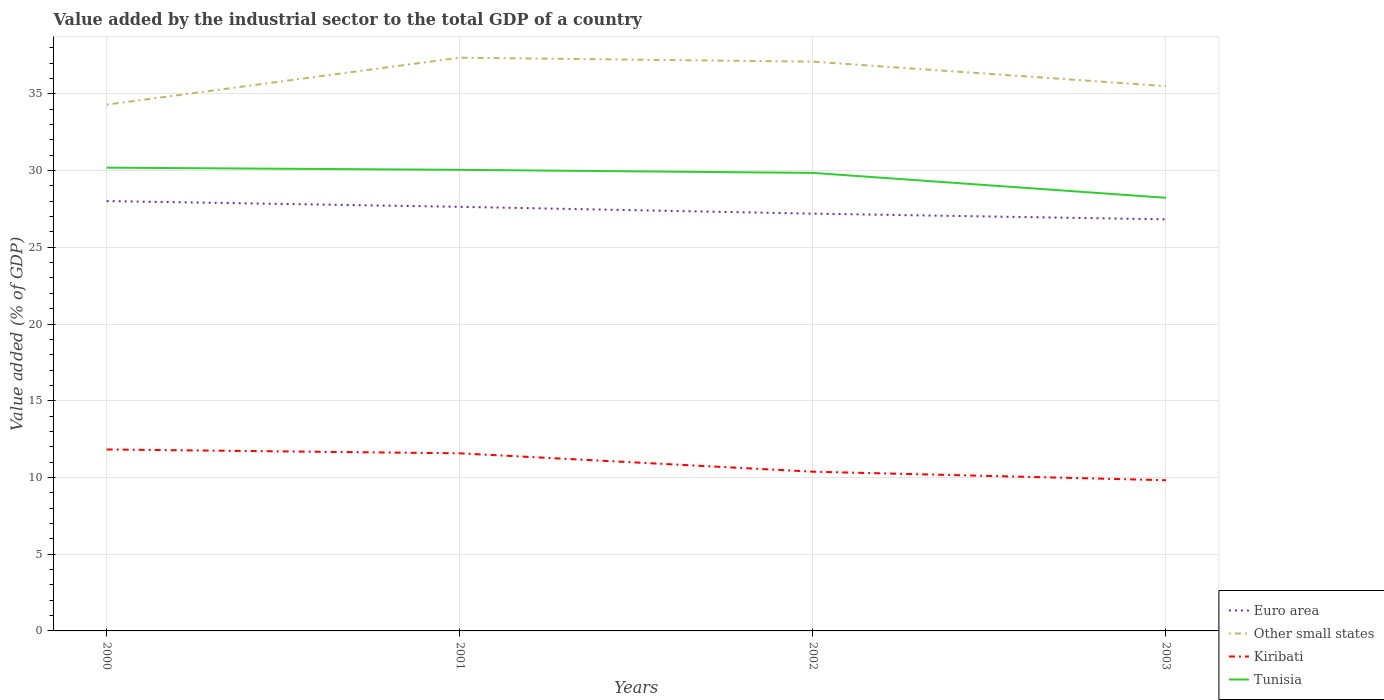Does the line corresponding to Kiribati intersect with the line corresponding to Tunisia?
Offer a very short reply. No. Across all years, what is the maximum value added by the industrial sector to the total GDP in Kiribati?
Your response must be concise. 9.82. What is the total value added by the industrial sector to the total GDP in Euro area in the graph?
Give a very brief answer. 0.45. What is the difference between the highest and the second highest value added by the industrial sector to the total GDP in Euro area?
Make the answer very short. 1.19. Is the value added by the industrial sector to the total GDP in Tunisia strictly greater than the value added by the industrial sector to the total GDP in Other small states over the years?
Your answer should be very brief. Yes. Are the values on the major ticks of Y-axis written in scientific E-notation?
Make the answer very short. No. Does the graph contain any zero values?
Give a very brief answer. No. Does the graph contain grids?
Give a very brief answer. Yes. What is the title of the graph?
Your answer should be compact. Value added by the industrial sector to the total GDP of a country. What is the label or title of the X-axis?
Offer a very short reply. Years. What is the label or title of the Y-axis?
Your answer should be compact. Value added (% of GDP). What is the Value added (% of GDP) in Euro area in 2000?
Provide a succinct answer. 28.01. What is the Value added (% of GDP) in Other small states in 2000?
Keep it short and to the point. 34.3. What is the Value added (% of GDP) in Kiribati in 2000?
Offer a terse response. 11.82. What is the Value added (% of GDP) of Tunisia in 2000?
Provide a short and direct response. 30.19. What is the Value added (% of GDP) of Euro area in 2001?
Your response must be concise. 27.64. What is the Value added (% of GDP) in Other small states in 2001?
Keep it short and to the point. 37.35. What is the Value added (% of GDP) in Kiribati in 2001?
Keep it short and to the point. 11.57. What is the Value added (% of GDP) in Tunisia in 2001?
Your answer should be very brief. 30.05. What is the Value added (% of GDP) of Euro area in 2002?
Provide a short and direct response. 27.19. What is the Value added (% of GDP) in Other small states in 2002?
Ensure brevity in your answer.  37.1. What is the Value added (% of GDP) of Kiribati in 2002?
Your answer should be very brief. 10.38. What is the Value added (% of GDP) of Tunisia in 2002?
Your answer should be very brief. 29.85. What is the Value added (% of GDP) of Euro area in 2003?
Provide a succinct answer. 26.82. What is the Value added (% of GDP) of Other small states in 2003?
Offer a terse response. 35.5. What is the Value added (% of GDP) in Kiribati in 2003?
Give a very brief answer. 9.82. What is the Value added (% of GDP) in Tunisia in 2003?
Offer a terse response. 28.23. Across all years, what is the maximum Value added (% of GDP) in Euro area?
Your response must be concise. 28.01. Across all years, what is the maximum Value added (% of GDP) in Other small states?
Your answer should be very brief. 37.35. Across all years, what is the maximum Value added (% of GDP) of Kiribati?
Make the answer very short. 11.82. Across all years, what is the maximum Value added (% of GDP) of Tunisia?
Make the answer very short. 30.19. Across all years, what is the minimum Value added (% of GDP) in Euro area?
Provide a short and direct response. 26.82. Across all years, what is the minimum Value added (% of GDP) of Other small states?
Your answer should be compact. 34.3. Across all years, what is the minimum Value added (% of GDP) in Kiribati?
Offer a very short reply. 9.82. Across all years, what is the minimum Value added (% of GDP) in Tunisia?
Keep it short and to the point. 28.23. What is the total Value added (% of GDP) in Euro area in the graph?
Offer a very short reply. 109.66. What is the total Value added (% of GDP) of Other small states in the graph?
Offer a terse response. 144.25. What is the total Value added (% of GDP) of Kiribati in the graph?
Keep it short and to the point. 43.6. What is the total Value added (% of GDP) of Tunisia in the graph?
Your answer should be very brief. 118.31. What is the difference between the Value added (% of GDP) of Euro area in 2000 and that in 2001?
Your answer should be compact. 0.37. What is the difference between the Value added (% of GDP) in Other small states in 2000 and that in 2001?
Provide a succinct answer. -3.06. What is the difference between the Value added (% of GDP) of Kiribati in 2000 and that in 2001?
Make the answer very short. 0.25. What is the difference between the Value added (% of GDP) of Tunisia in 2000 and that in 2001?
Provide a short and direct response. 0.14. What is the difference between the Value added (% of GDP) in Euro area in 2000 and that in 2002?
Keep it short and to the point. 0.82. What is the difference between the Value added (% of GDP) in Other small states in 2000 and that in 2002?
Offer a terse response. -2.8. What is the difference between the Value added (% of GDP) in Kiribati in 2000 and that in 2002?
Your response must be concise. 1.45. What is the difference between the Value added (% of GDP) in Tunisia in 2000 and that in 2002?
Keep it short and to the point. 0.34. What is the difference between the Value added (% of GDP) of Euro area in 2000 and that in 2003?
Provide a short and direct response. 1.19. What is the difference between the Value added (% of GDP) of Other small states in 2000 and that in 2003?
Ensure brevity in your answer.  -1.21. What is the difference between the Value added (% of GDP) in Kiribati in 2000 and that in 2003?
Keep it short and to the point. 2. What is the difference between the Value added (% of GDP) of Tunisia in 2000 and that in 2003?
Keep it short and to the point. 1.96. What is the difference between the Value added (% of GDP) in Euro area in 2001 and that in 2002?
Give a very brief answer. 0.45. What is the difference between the Value added (% of GDP) of Other small states in 2001 and that in 2002?
Offer a very short reply. 0.26. What is the difference between the Value added (% of GDP) in Kiribati in 2001 and that in 2002?
Offer a terse response. 1.2. What is the difference between the Value added (% of GDP) of Tunisia in 2001 and that in 2002?
Your answer should be compact. 0.2. What is the difference between the Value added (% of GDP) in Euro area in 2001 and that in 2003?
Your answer should be very brief. 0.82. What is the difference between the Value added (% of GDP) in Other small states in 2001 and that in 2003?
Offer a very short reply. 1.85. What is the difference between the Value added (% of GDP) of Kiribati in 2001 and that in 2003?
Give a very brief answer. 1.75. What is the difference between the Value added (% of GDP) of Tunisia in 2001 and that in 2003?
Your answer should be compact. 1.82. What is the difference between the Value added (% of GDP) of Euro area in 2002 and that in 2003?
Give a very brief answer. 0.37. What is the difference between the Value added (% of GDP) in Other small states in 2002 and that in 2003?
Ensure brevity in your answer.  1.59. What is the difference between the Value added (% of GDP) of Kiribati in 2002 and that in 2003?
Give a very brief answer. 0.55. What is the difference between the Value added (% of GDP) of Tunisia in 2002 and that in 2003?
Keep it short and to the point. 1.62. What is the difference between the Value added (% of GDP) of Euro area in 2000 and the Value added (% of GDP) of Other small states in 2001?
Your answer should be very brief. -9.34. What is the difference between the Value added (% of GDP) of Euro area in 2000 and the Value added (% of GDP) of Kiribati in 2001?
Keep it short and to the point. 16.44. What is the difference between the Value added (% of GDP) of Euro area in 2000 and the Value added (% of GDP) of Tunisia in 2001?
Make the answer very short. -2.04. What is the difference between the Value added (% of GDP) in Other small states in 2000 and the Value added (% of GDP) in Kiribati in 2001?
Make the answer very short. 22.72. What is the difference between the Value added (% of GDP) in Other small states in 2000 and the Value added (% of GDP) in Tunisia in 2001?
Give a very brief answer. 4.25. What is the difference between the Value added (% of GDP) in Kiribati in 2000 and the Value added (% of GDP) in Tunisia in 2001?
Keep it short and to the point. -18.22. What is the difference between the Value added (% of GDP) in Euro area in 2000 and the Value added (% of GDP) in Other small states in 2002?
Provide a short and direct response. -9.08. What is the difference between the Value added (% of GDP) in Euro area in 2000 and the Value added (% of GDP) in Kiribati in 2002?
Your response must be concise. 17.64. What is the difference between the Value added (% of GDP) of Euro area in 2000 and the Value added (% of GDP) of Tunisia in 2002?
Your answer should be compact. -1.84. What is the difference between the Value added (% of GDP) of Other small states in 2000 and the Value added (% of GDP) of Kiribati in 2002?
Ensure brevity in your answer.  23.92. What is the difference between the Value added (% of GDP) in Other small states in 2000 and the Value added (% of GDP) in Tunisia in 2002?
Your answer should be very brief. 4.45. What is the difference between the Value added (% of GDP) of Kiribati in 2000 and the Value added (% of GDP) of Tunisia in 2002?
Your answer should be very brief. -18.02. What is the difference between the Value added (% of GDP) of Euro area in 2000 and the Value added (% of GDP) of Other small states in 2003?
Your answer should be compact. -7.49. What is the difference between the Value added (% of GDP) in Euro area in 2000 and the Value added (% of GDP) in Kiribati in 2003?
Provide a short and direct response. 18.19. What is the difference between the Value added (% of GDP) in Euro area in 2000 and the Value added (% of GDP) in Tunisia in 2003?
Keep it short and to the point. -0.21. What is the difference between the Value added (% of GDP) in Other small states in 2000 and the Value added (% of GDP) in Kiribati in 2003?
Keep it short and to the point. 24.47. What is the difference between the Value added (% of GDP) in Other small states in 2000 and the Value added (% of GDP) in Tunisia in 2003?
Your answer should be very brief. 6.07. What is the difference between the Value added (% of GDP) in Kiribati in 2000 and the Value added (% of GDP) in Tunisia in 2003?
Keep it short and to the point. -16.4. What is the difference between the Value added (% of GDP) of Euro area in 2001 and the Value added (% of GDP) of Other small states in 2002?
Keep it short and to the point. -9.46. What is the difference between the Value added (% of GDP) of Euro area in 2001 and the Value added (% of GDP) of Kiribati in 2002?
Provide a short and direct response. 17.26. What is the difference between the Value added (% of GDP) in Euro area in 2001 and the Value added (% of GDP) in Tunisia in 2002?
Your response must be concise. -2.21. What is the difference between the Value added (% of GDP) in Other small states in 2001 and the Value added (% of GDP) in Kiribati in 2002?
Give a very brief answer. 26.98. What is the difference between the Value added (% of GDP) of Other small states in 2001 and the Value added (% of GDP) of Tunisia in 2002?
Offer a very short reply. 7.51. What is the difference between the Value added (% of GDP) in Kiribati in 2001 and the Value added (% of GDP) in Tunisia in 2002?
Make the answer very short. -18.27. What is the difference between the Value added (% of GDP) of Euro area in 2001 and the Value added (% of GDP) of Other small states in 2003?
Ensure brevity in your answer.  -7.87. What is the difference between the Value added (% of GDP) of Euro area in 2001 and the Value added (% of GDP) of Kiribati in 2003?
Provide a short and direct response. 17.82. What is the difference between the Value added (% of GDP) in Euro area in 2001 and the Value added (% of GDP) in Tunisia in 2003?
Ensure brevity in your answer.  -0.59. What is the difference between the Value added (% of GDP) in Other small states in 2001 and the Value added (% of GDP) in Kiribati in 2003?
Ensure brevity in your answer.  27.53. What is the difference between the Value added (% of GDP) of Other small states in 2001 and the Value added (% of GDP) of Tunisia in 2003?
Offer a terse response. 9.13. What is the difference between the Value added (% of GDP) in Kiribati in 2001 and the Value added (% of GDP) in Tunisia in 2003?
Ensure brevity in your answer.  -16.65. What is the difference between the Value added (% of GDP) in Euro area in 2002 and the Value added (% of GDP) in Other small states in 2003?
Provide a short and direct response. -8.31. What is the difference between the Value added (% of GDP) of Euro area in 2002 and the Value added (% of GDP) of Kiribati in 2003?
Provide a short and direct response. 17.37. What is the difference between the Value added (% of GDP) in Euro area in 2002 and the Value added (% of GDP) in Tunisia in 2003?
Give a very brief answer. -1.03. What is the difference between the Value added (% of GDP) in Other small states in 2002 and the Value added (% of GDP) in Kiribati in 2003?
Your answer should be very brief. 27.27. What is the difference between the Value added (% of GDP) in Other small states in 2002 and the Value added (% of GDP) in Tunisia in 2003?
Provide a short and direct response. 8.87. What is the difference between the Value added (% of GDP) in Kiribati in 2002 and the Value added (% of GDP) in Tunisia in 2003?
Offer a terse response. -17.85. What is the average Value added (% of GDP) in Euro area per year?
Make the answer very short. 27.42. What is the average Value added (% of GDP) in Other small states per year?
Give a very brief answer. 36.06. What is the average Value added (% of GDP) of Kiribati per year?
Offer a very short reply. 10.9. What is the average Value added (% of GDP) in Tunisia per year?
Offer a terse response. 29.58. In the year 2000, what is the difference between the Value added (% of GDP) in Euro area and Value added (% of GDP) in Other small states?
Offer a very short reply. -6.28. In the year 2000, what is the difference between the Value added (% of GDP) in Euro area and Value added (% of GDP) in Kiribati?
Offer a terse response. 16.19. In the year 2000, what is the difference between the Value added (% of GDP) of Euro area and Value added (% of GDP) of Tunisia?
Make the answer very short. -2.18. In the year 2000, what is the difference between the Value added (% of GDP) of Other small states and Value added (% of GDP) of Kiribati?
Offer a very short reply. 22.47. In the year 2000, what is the difference between the Value added (% of GDP) of Other small states and Value added (% of GDP) of Tunisia?
Provide a short and direct response. 4.11. In the year 2000, what is the difference between the Value added (% of GDP) in Kiribati and Value added (% of GDP) in Tunisia?
Your response must be concise. -18.36. In the year 2001, what is the difference between the Value added (% of GDP) in Euro area and Value added (% of GDP) in Other small states?
Ensure brevity in your answer.  -9.72. In the year 2001, what is the difference between the Value added (% of GDP) in Euro area and Value added (% of GDP) in Kiribati?
Ensure brevity in your answer.  16.06. In the year 2001, what is the difference between the Value added (% of GDP) in Euro area and Value added (% of GDP) in Tunisia?
Make the answer very short. -2.41. In the year 2001, what is the difference between the Value added (% of GDP) of Other small states and Value added (% of GDP) of Kiribati?
Provide a short and direct response. 25.78. In the year 2001, what is the difference between the Value added (% of GDP) of Other small states and Value added (% of GDP) of Tunisia?
Provide a succinct answer. 7.31. In the year 2001, what is the difference between the Value added (% of GDP) of Kiribati and Value added (% of GDP) of Tunisia?
Give a very brief answer. -18.47. In the year 2002, what is the difference between the Value added (% of GDP) of Euro area and Value added (% of GDP) of Other small states?
Offer a terse response. -9.9. In the year 2002, what is the difference between the Value added (% of GDP) of Euro area and Value added (% of GDP) of Kiribati?
Offer a very short reply. 16.82. In the year 2002, what is the difference between the Value added (% of GDP) in Euro area and Value added (% of GDP) in Tunisia?
Make the answer very short. -2.66. In the year 2002, what is the difference between the Value added (% of GDP) of Other small states and Value added (% of GDP) of Kiribati?
Your answer should be very brief. 26.72. In the year 2002, what is the difference between the Value added (% of GDP) of Other small states and Value added (% of GDP) of Tunisia?
Your response must be concise. 7.25. In the year 2002, what is the difference between the Value added (% of GDP) of Kiribati and Value added (% of GDP) of Tunisia?
Keep it short and to the point. -19.47. In the year 2003, what is the difference between the Value added (% of GDP) of Euro area and Value added (% of GDP) of Other small states?
Your response must be concise. -8.68. In the year 2003, what is the difference between the Value added (% of GDP) in Euro area and Value added (% of GDP) in Kiribati?
Ensure brevity in your answer.  17. In the year 2003, what is the difference between the Value added (% of GDP) in Euro area and Value added (% of GDP) in Tunisia?
Provide a short and direct response. -1.4. In the year 2003, what is the difference between the Value added (% of GDP) of Other small states and Value added (% of GDP) of Kiribati?
Your answer should be compact. 25.68. In the year 2003, what is the difference between the Value added (% of GDP) of Other small states and Value added (% of GDP) of Tunisia?
Offer a very short reply. 7.28. In the year 2003, what is the difference between the Value added (% of GDP) of Kiribati and Value added (% of GDP) of Tunisia?
Offer a terse response. -18.4. What is the ratio of the Value added (% of GDP) in Euro area in 2000 to that in 2001?
Keep it short and to the point. 1.01. What is the ratio of the Value added (% of GDP) of Other small states in 2000 to that in 2001?
Ensure brevity in your answer.  0.92. What is the ratio of the Value added (% of GDP) of Kiribati in 2000 to that in 2001?
Ensure brevity in your answer.  1.02. What is the ratio of the Value added (% of GDP) in Euro area in 2000 to that in 2002?
Provide a succinct answer. 1.03. What is the ratio of the Value added (% of GDP) of Other small states in 2000 to that in 2002?
Give a very brief answer. 0.92. What is the ratio of the Value added (% of GDP) in Kiribati in 2000 to that in 2002?
Ensure brevity in your answer.  1.14. What is the ratio of the Value added (% of GDP) in Tunisia in 2000 to that in 2002?
Offer a terse response. 1.01. What is the ratio of the Value added (% of GDP) of Euro area in 2000 to that in 2003?
Ensure brevity in your answer.  1.04. What is the ratio of the Value added (% of GDP) in Other small states in 2000 to that in 2003?
Your answer should be very brief. 0.97. What is the ratio of the Value added (% of GDP) in Kiribati in 2000 to that in 2003?
Give a very brief answer. 1.2. What is the ratio of the Value added (% of GDP) in Tunisia in 2000 to that in 2003?
Your response must be concise. 1.07. What is the ratio of the Value added (% of GDP) in Euro area in 2001 to that in 2002?
Your answer should be very brief. 1.02. What is the ratio of the Value added (% of GDP) of Kiribati in 2001 to that in 2002?
Provide a succinct answer. 1.12. What is the ratio of the Value added (% of GDP) in Euro area in 2001 to that in 2003?
Your answer should be very brief. 1.03. What is the ratio of the Value added (% of GDP) in Other small states in 2001 to that in 2003?
Ensure brevity in your answer.  1.05. What is the ratio of the Value added (% of GDP) in Kiribati in 2001 to that in 2003?
Make the answer very short. 1.18. What is the ratio of the Value added (% of GDP) of Tunisia in 2001 to that in 2003?
Give a very brief answer. 1.06. What is the ratio of the Value added (% of GDP) in Euro area in 2002 to that in 2003?
Your answer should be very brief. 1.01. What is the ratio of the Value added (% of GDP) in Other small states in 2002 to that in 2003?
Make the answer very short. 1.04. What is the ratio of the Value added (% of GDP) in Kiribati in 2002 to that in 2003?
Offer a very short reply. 1.06. What is the ratio of the Value added (% of GDP) in Tunisia in 2002 to that in 2003?
Your answer should be very brief. 1.06. What is the difference between the highest and the second highest Value added (% of GDP) of Euro area?
Offer a very short reply. 0.37. What is the difference between the highest and the second highest Value added (% of GDP) in Other small states?
Make the answer very short. 0.26. What is the difference between the highest and the second highest Value added (% of GDP) in Kiribati?
Your answer should be compact. 0.25. What is the difference between the highest and the second highest Value added (% of GDP) of Tunisia?
Your answer should be very brief. 0.14. What is the difference between the highest and the lowest Value added (% of GDP) of Euro area?
Ensure brevity in your answer.  1.19. What is the difference between the highest and the lowest Value added (% of GDP) of Other small states?
Provide a short and direct response. 3.06. What is the difference between the highest and the lowest Value added (% of GDP) in Kiribati?
Keep it short and to the point. 2. What is the difference between the highest and the lowest Value added (% of GDP) of Tunisia?
Your response must be concise. 1.96. 